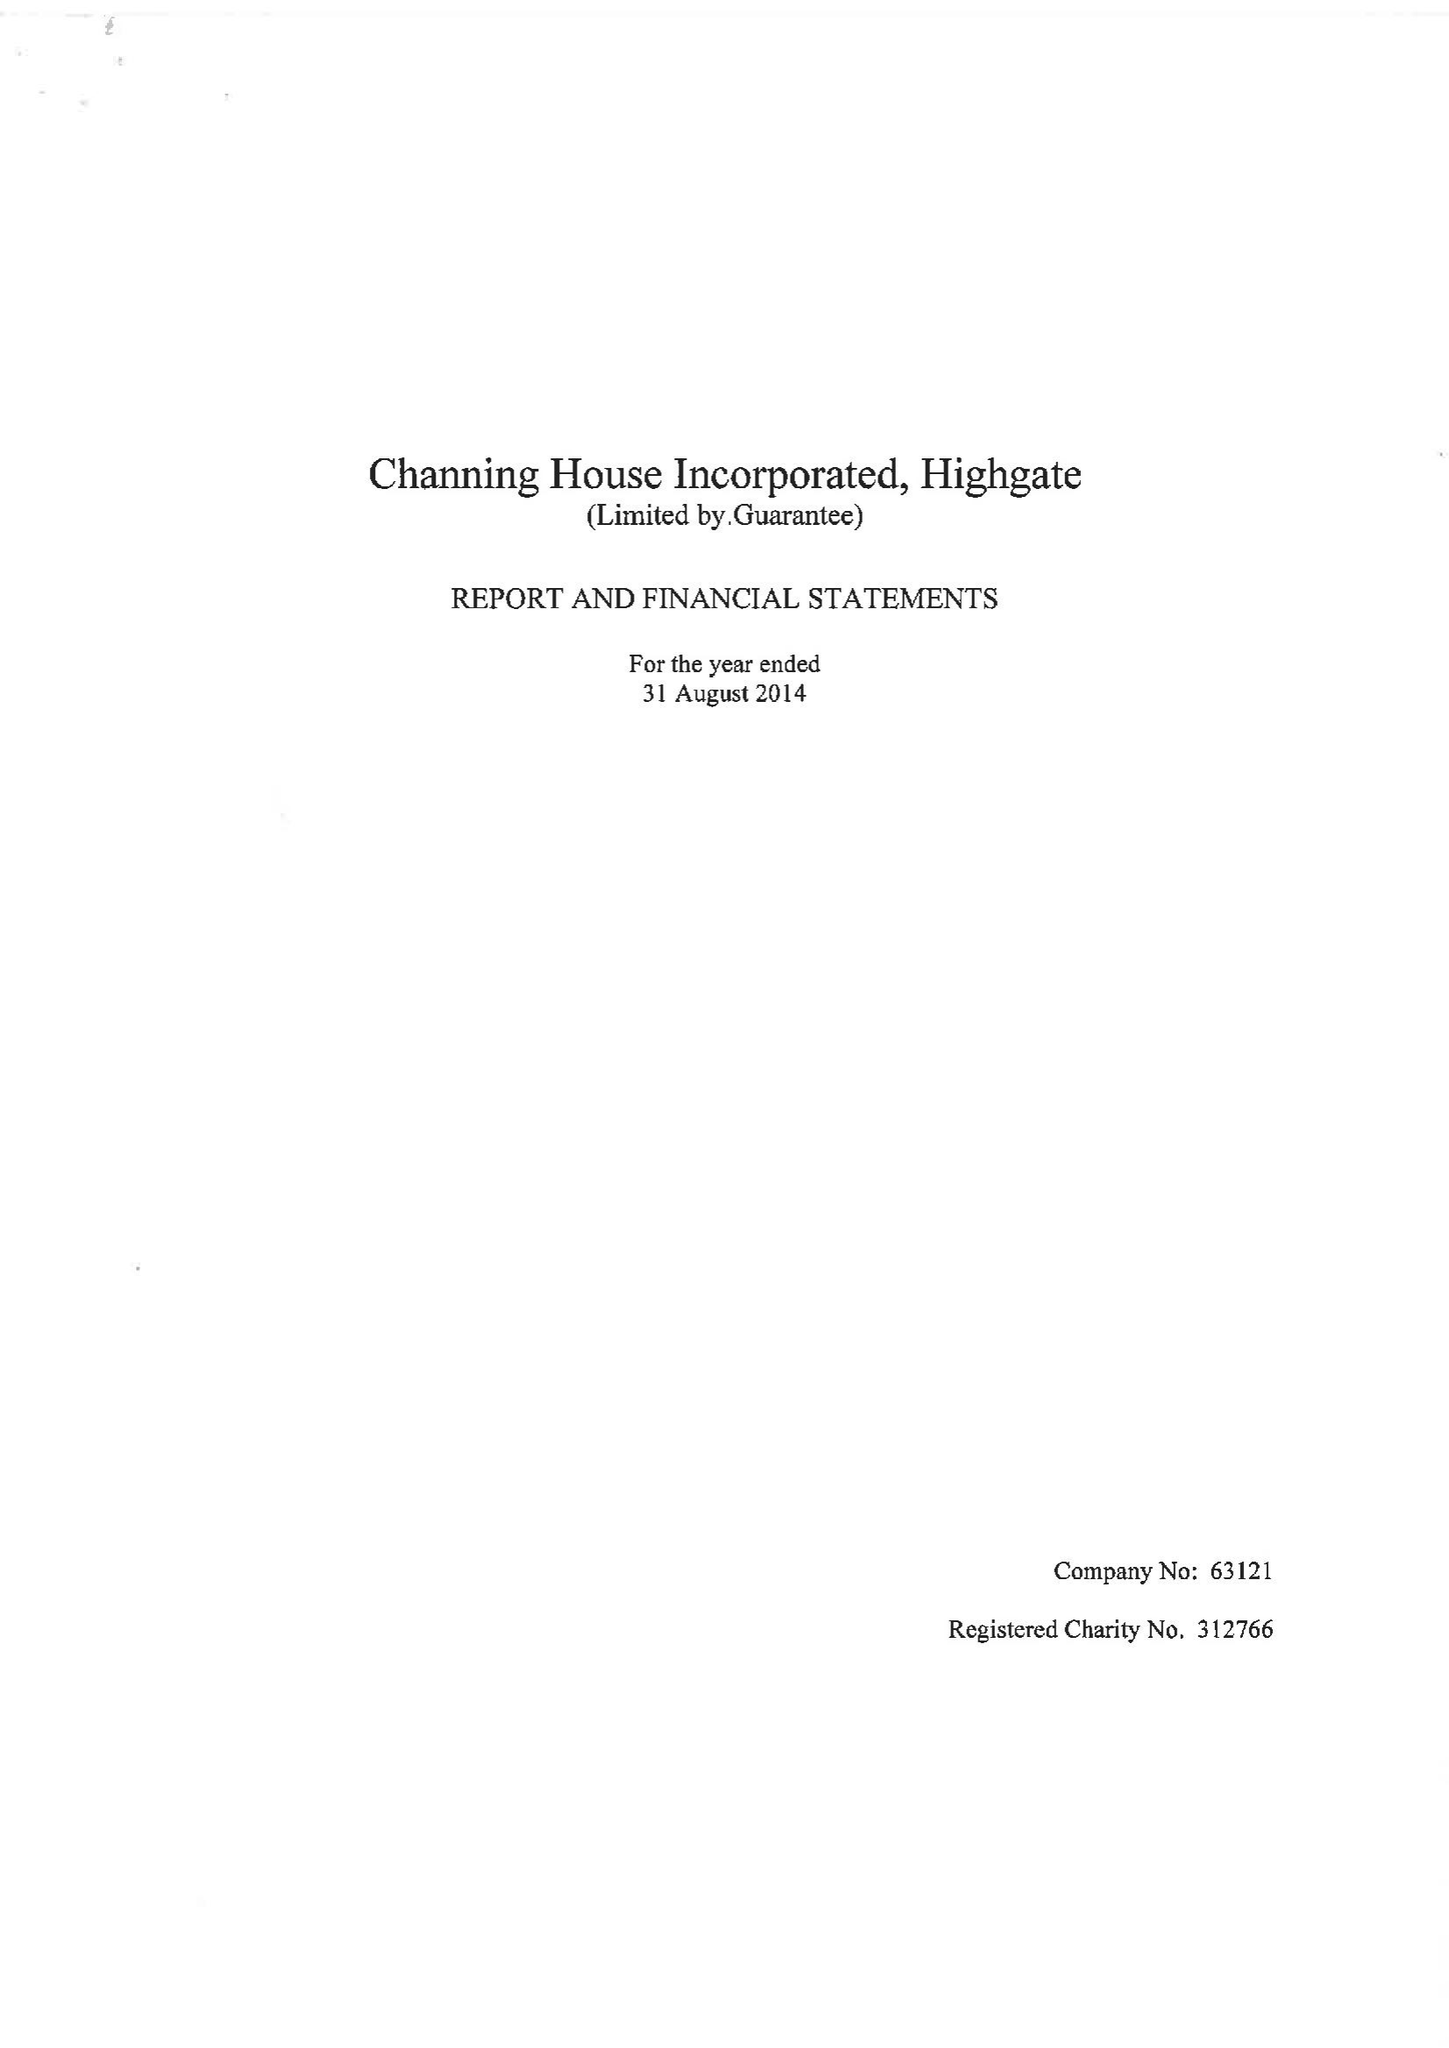What is the value for the address__postcode?
Answer the question using a single word or phrase. N6 5HF 